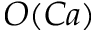Convert formula to latex. <formula><loc_0><loc_0><loc_500><loc_500>O ( C a )</formula> 